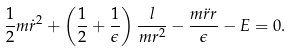<formula> <loc_0><loc_0><loc_500><loc_500>\frac { 1 } { 2 } m \dot { r } ^ { 2 } + \left ( \frac { 1 } { 2 } + \frac { 1 } { \epsilon } \right ) \frac { l } { m r ^ { 2 } } - \frac { m \ddot { r } r } { \epsilon } - E = 0 .</formula> 